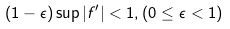Convert formula to latex. <formula><loc_0><loc_0><loc_500><loc_500>( 1 - \epsilon ) \sup | f ^ { \prime } | < 1 , ( 0 \leq \epsilon < 1 )</formula> 